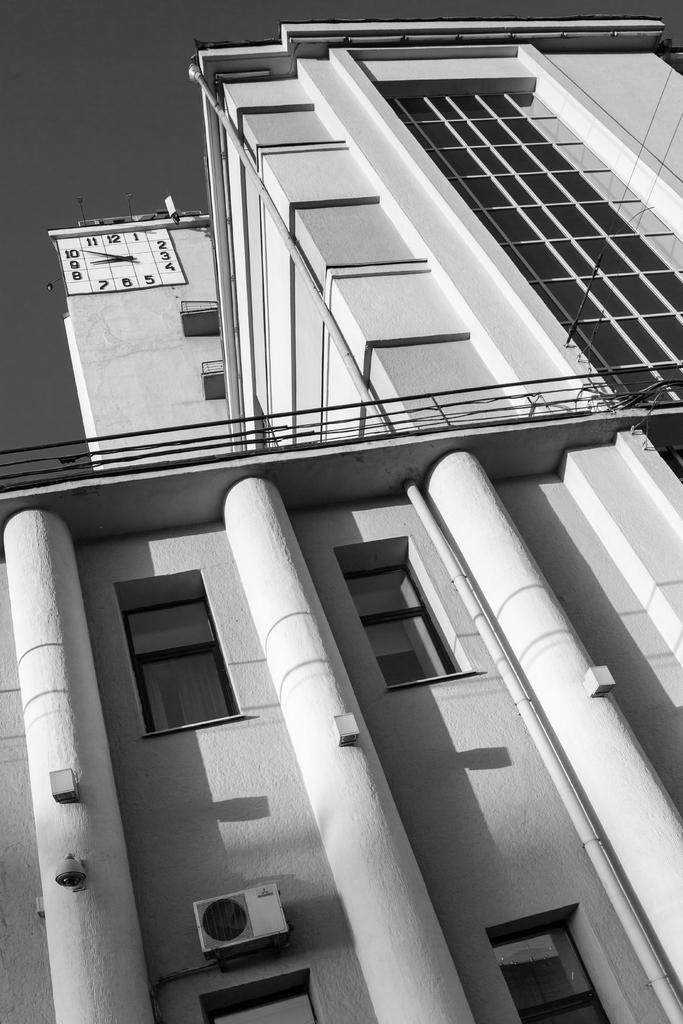What type of structure is present in the image? There is a building in the image. What are some features of the building? The building has windows and glasses. Is there any time-related object visible in the image? Yes, there is a clock on the wall at the top of the building. Can you see any volcanoes erupting in the image? No, there are no volcanoes present in the image. How many crows are perched on the building in the image? There are no crows visible in the image. 